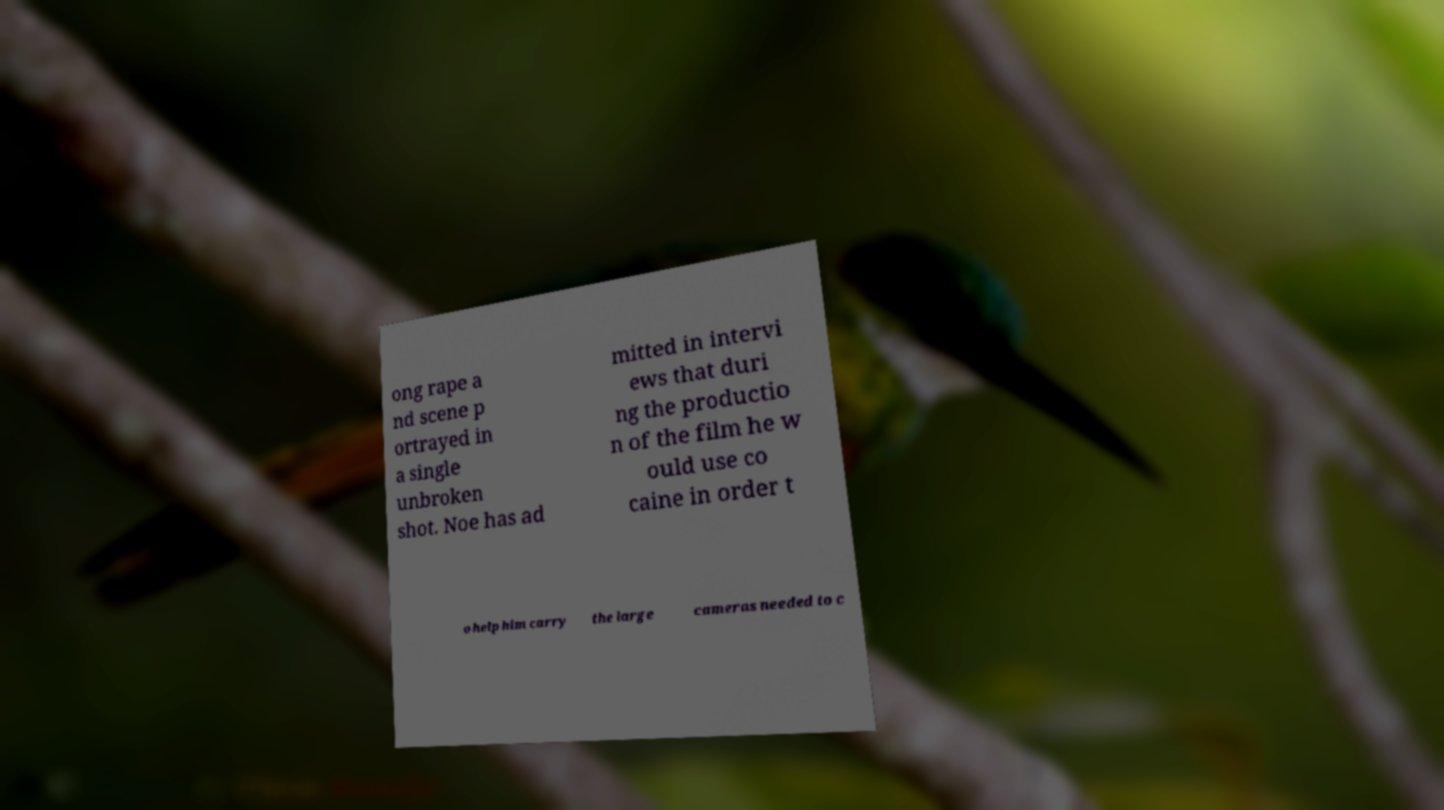I need the written content from this picture converted into text. Can you do that? ong rape a nd scene p ortrayed in a single unbroken shot. Noe has ad mitted in intervi ews that duri ng the productio n of the film he w ould use co caine in order t o help him carry the large cameras needed to c 